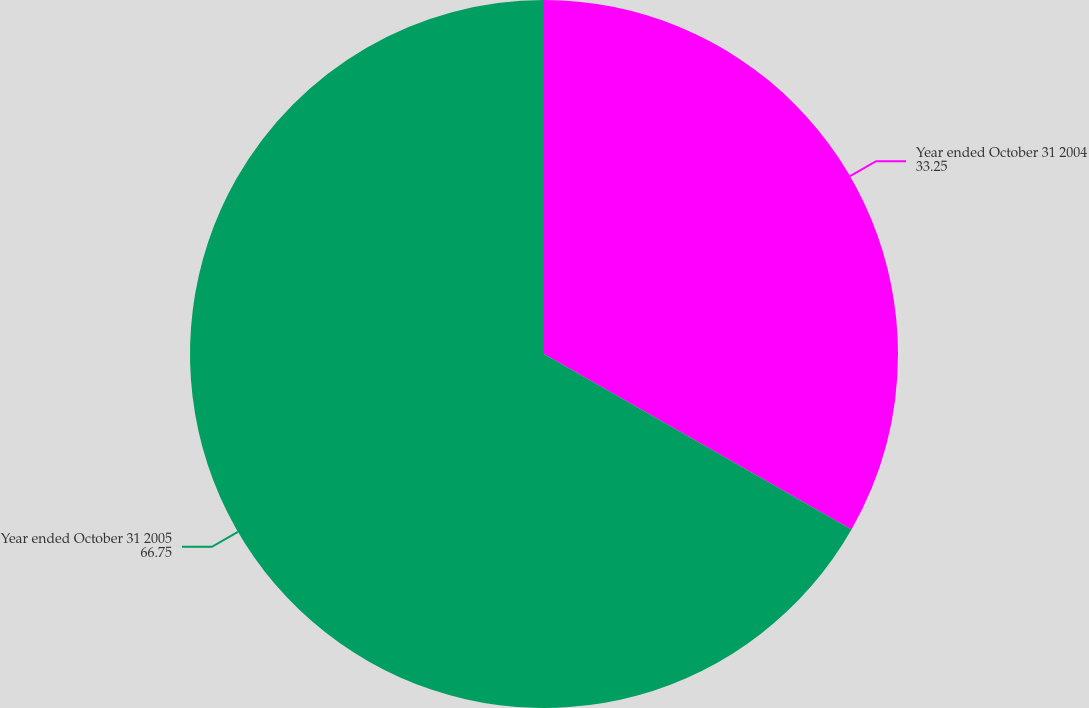Convert chart to OTSL. <chart><loc_0><loc_0><loc_500><loc_500><pie_chart><fcel>Year ended October 31 2004<fcel>Year ended October 31 2005<nl><fcel>33.25%<fcel>66.75%<nl></chart> 